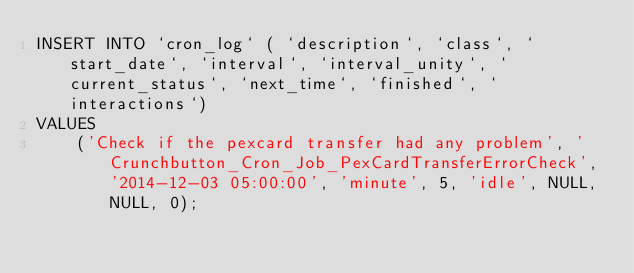Convert code to text. <code><loc_0><loc_0><loc_500><loc_500><_SQL_>INSERT INTO `cron_log` ( `description`, `class`, `start_date`, `interval`, `interval_unity`, `current_status`, `next_time`, `finished`, `interactions`)
VALUES
	('Check if the pexcard transfer had any problem', 'Crunchbutton_Cron_Job_PexCardTransferErrorCheck', '2014-12-03 05:00:00', 'minute', 5, 'idle', NULL, NULL, 0);
</code> 